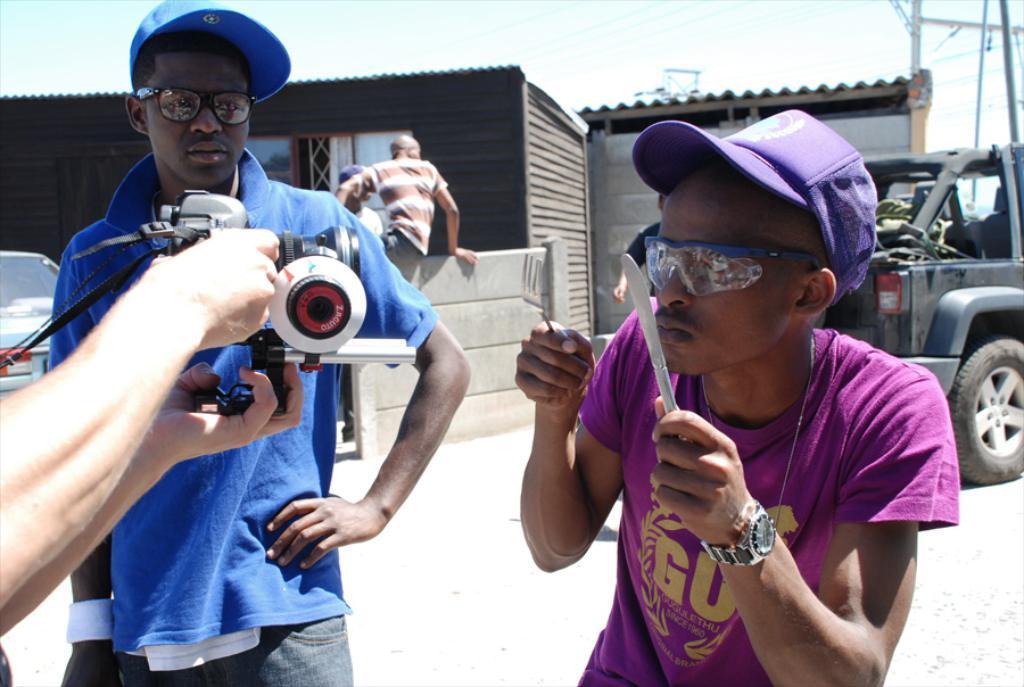Describe this image in one or two sentences. This picture describes about group of people, few people wore caps and spectacles, on the left side of the image we can see a person is holding a camera, in front of the camera we can see a man, he is holding a fork and knife, in the background we can find few cars, poles and buildings. 